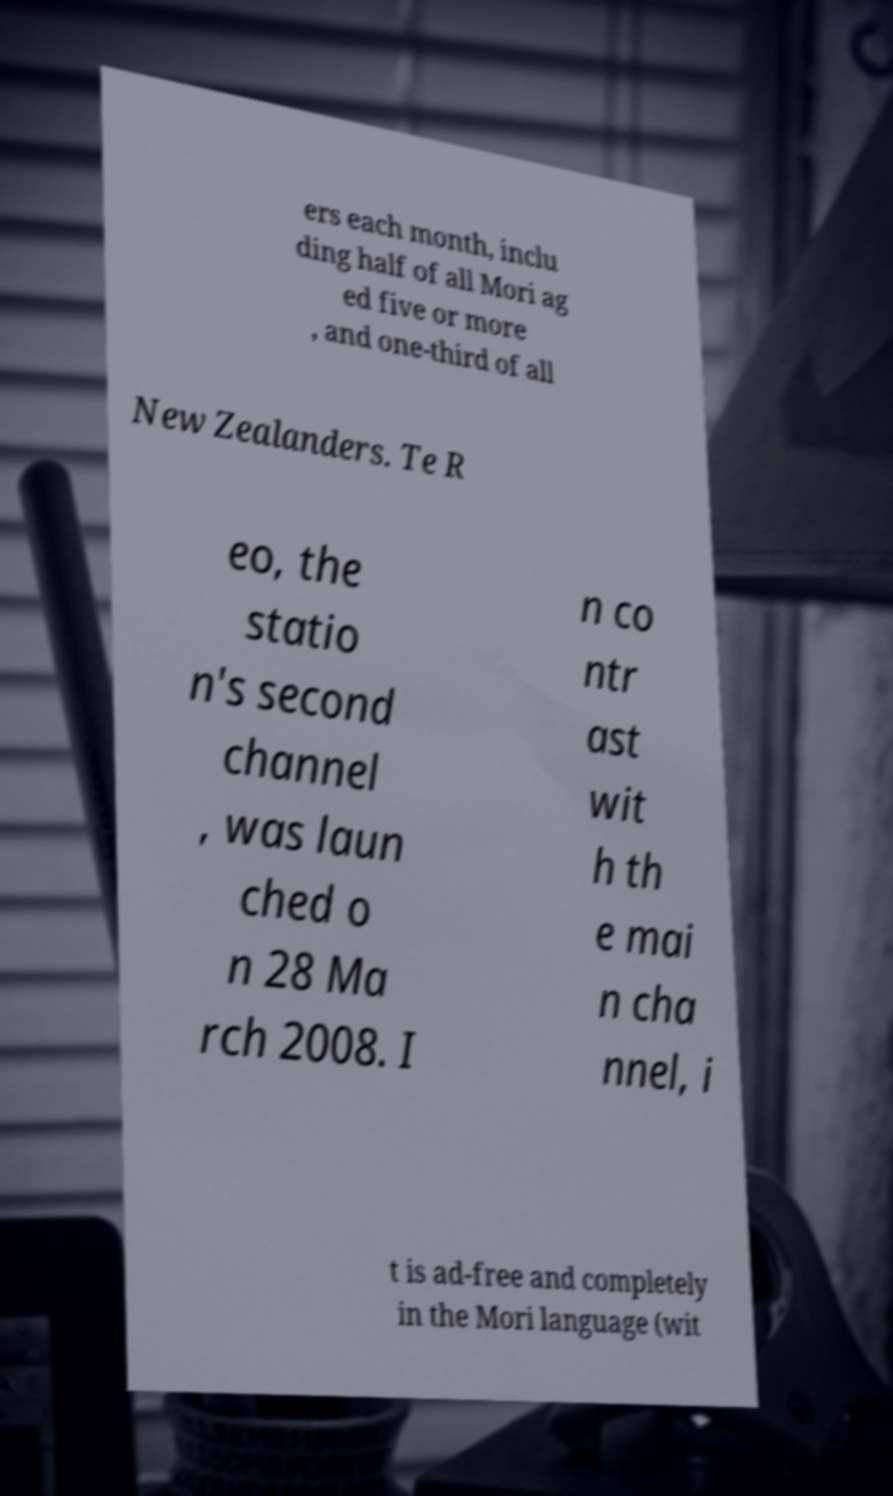There's text embedded in this image that I need extracted. Can you transcribe it verbatim? ers each month, inclu ding half of all Mori ag ed five or more , and one-third of all New Zealanders. Te R eo, the statio n's second channel , was laun ched o n 28 Ma rch 2008. I n co ntr ast wit h th e mai n cha nnel, i t is ad-free and completely in the Mori language (wit 